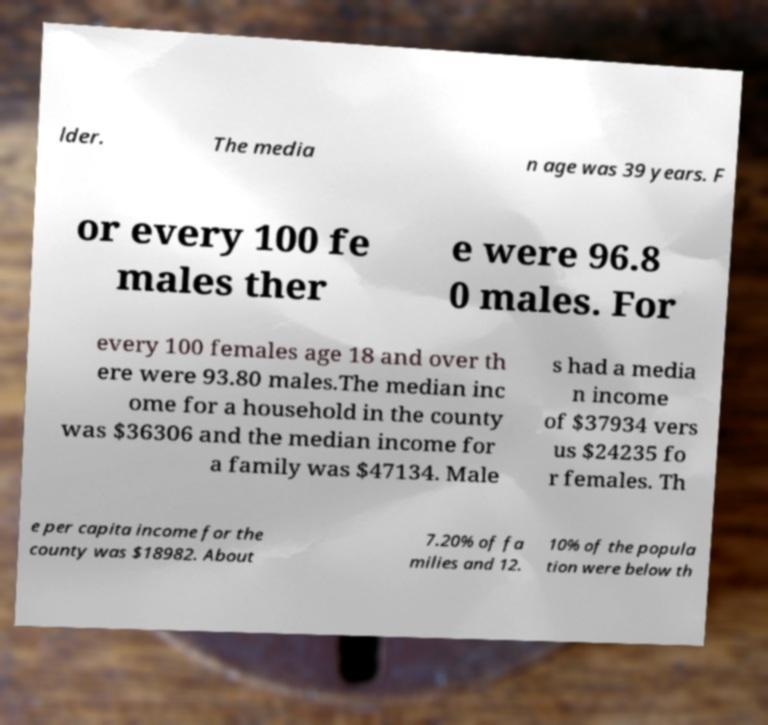What messages or text are displayed in this image? I need them in a readable, typed format. lder. The media n age was 39 years. F or every 100 fe males ther e were 96.8 0 males. For every 100 females age 18 and over th ere were 93.80 males.The median inc ome for a household in the county was $36306 and the median income for a family was $47134. Male s had a media n income of $37934 vers us $24235 fo r females. Th e per capita income for the county was $18982. About 7.20% of fa milies and 12. 10% of the popula tion were below th 